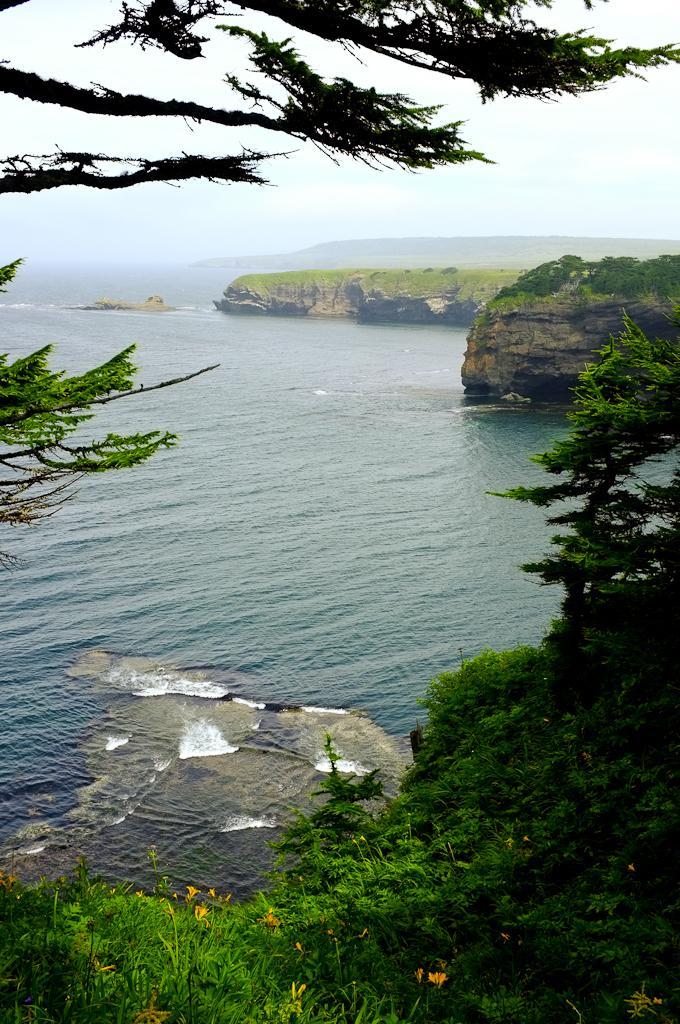In one or two sentences, can you explain what this image depicts? In this image we can see water. Also there are trees and plants with flowers. In the background there are hills and sky. 